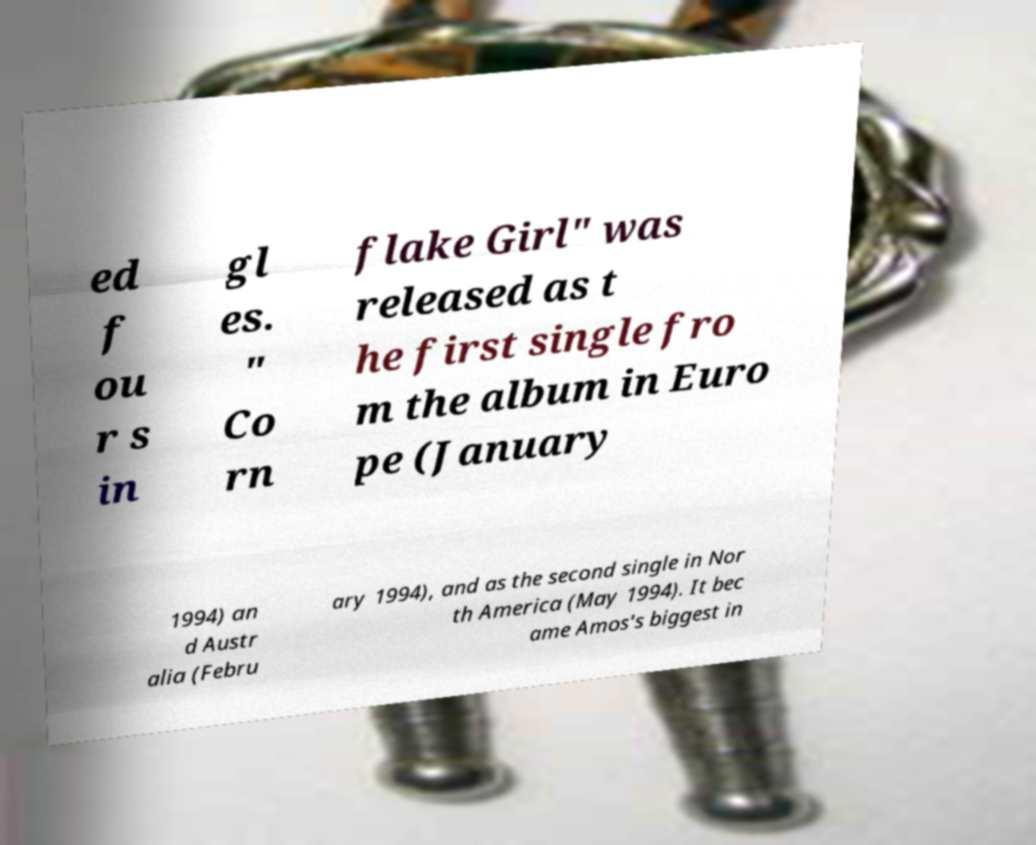Could you extract and type out the text from this image? ed f ou r s in gl es. " Co rn flake Girl" was released as t he first single fro m the album in Euro pe (January 1994) an d Austr alia (Febru ary 1994), and as the second single in Nor th America (May 1994). It bec ame Amos's biggest in 